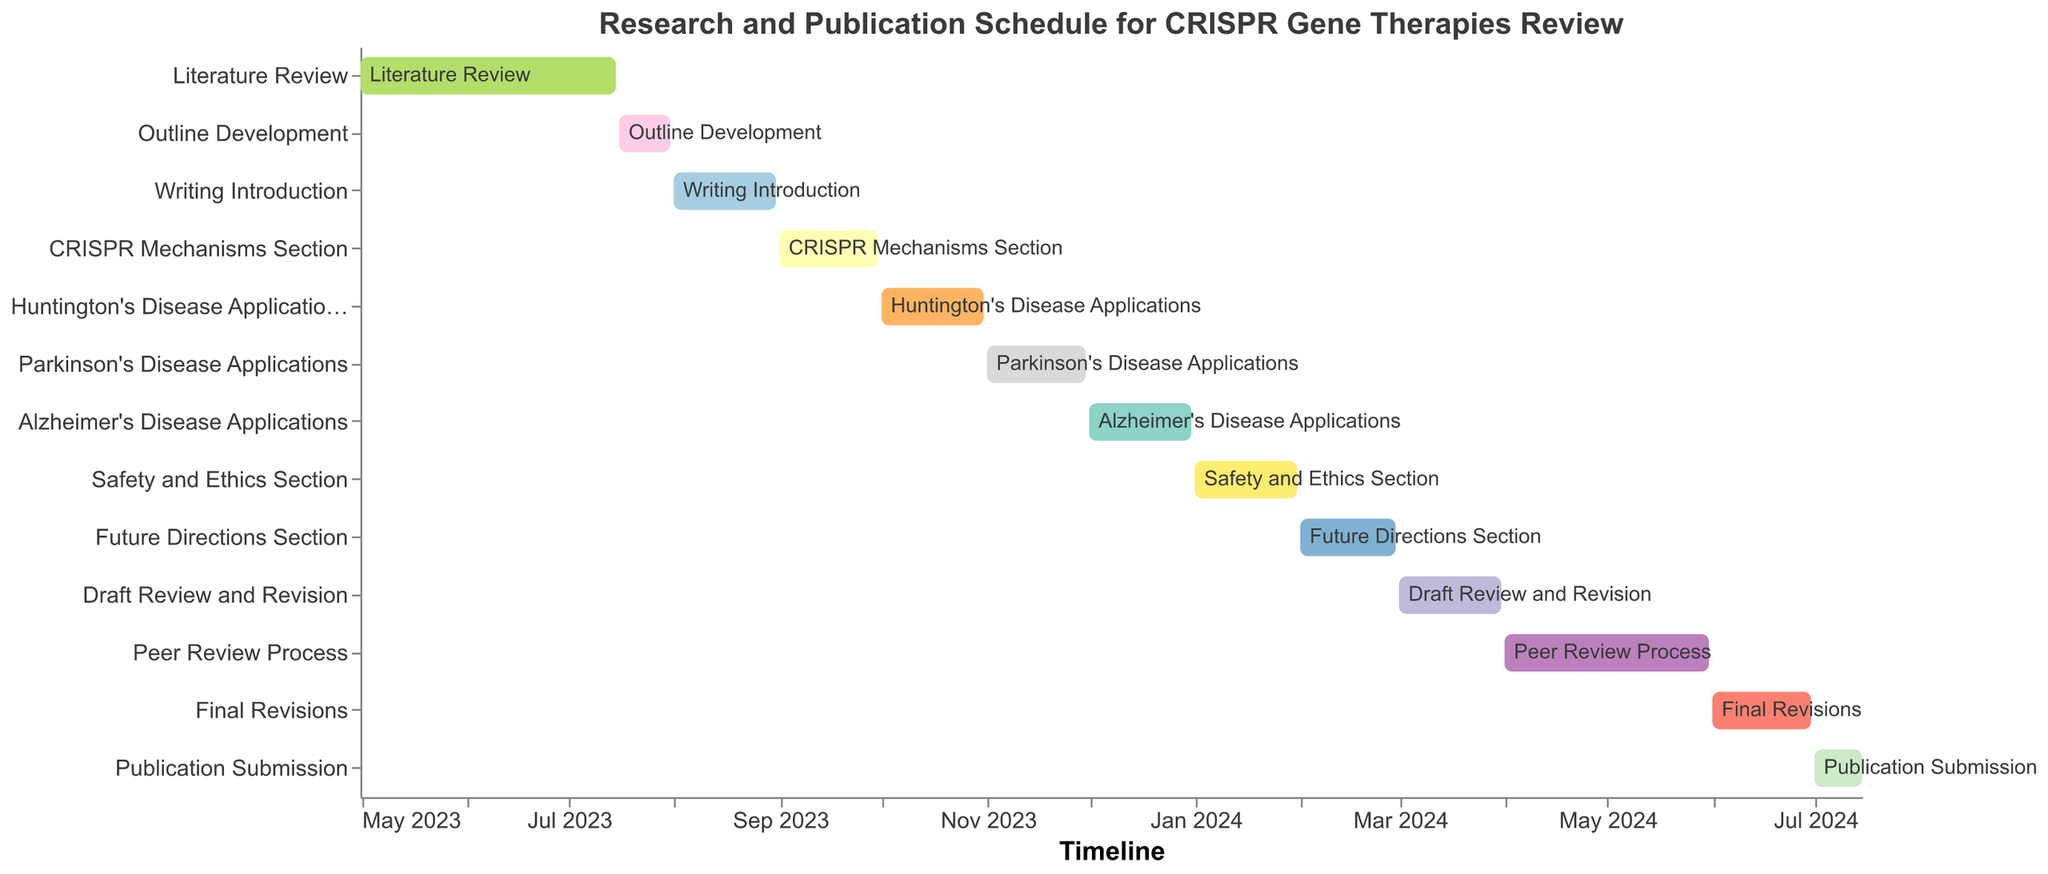What is the first task in the research and publication schedule? The Gantt Chart visually starts with the "Literature Review" task, which is positioned at the top and begins on the earliest date in the timeline, May 1, 2023.
Answer: Literature Review What is the duration of the "Writing Introduction" task? The "Writing Introduction" task starts on August 1, 2023, and ends on August 31, 2023. The duration is the difference between these dates.
Answer: 31 days Which task has the shortest duration? By examining the start and end dates of all tasks, we see the "Outline Development" task from July 16, 2023, to July 31, 2023, has the shortest duration.
Answer: Outline Development How many tasks are scheduled to be completed in the year 2023? There are seven tasks scheduled to finish in 2023: Literature Review, Outline Development, Writing Introduction, CRISPR Mechanisms Section, Huntington's Disease Applications, Parkinson's Disease Applications, and Alzheimer's Disease Applications.
Answer: 7 Which task overlaps with the "Peer Review Process" and by how many days? The "Peer Review Process" overlaps with "Draft Review and Revision" and "Final Revisions". "Peer Review Process" begins on April 1, 2024, and "Draft Review and Revision" ends on March 31, 2024, so there is no overlap. "Final Revisions" overlap by exactly 30 days: April 1, 2024, to April 30, 2024.
Answer: Final Revisions; 30 days Which task takes place in February 2024, and what is its duration? The "Future Directions Section" task starts on February 1, 2024, and ends on February 29, 2024, covering the whole month. The duration is 29 days.
Answer: Future Directions Section; 29 days When does the "Safety and Ethics Section" task start and end? The "Safety and Ethics Section" task starts on January 1, 2024, and ends on January 31, 2024.
Answer: January 1, 2024; January 31, 2024 Between which two tasks does the "CRISPR Mechanisms Section" task fall? The "CRISPR Mechanisms Section" task falls between the "Writing Introduction," which ends on August 31, 2023, and "Huntington's Disease Applications," which starts on October 1, 2023.
Answer: Writing Introduction; Huntington's Disease Applications Which tasks are scheduled to occur after the "Final Revisions" task? The "Final Revisions" task ends on June 30, 2024. The subsequent task is "Publication Submission," starting on July 1, 2024.
Answer: Publication Submission How long does the entire research and publication schedule span, from the start of the first task to the end of the last? The entire schedule starts with the "Literature Review" on May 1, 2023, and ends with "Publication Submission" on July 15, 2024. The span is 14.5 months, calculated by counting the complete months from May 2023 to June 2024 plus half of July 2024.
Answer: 14.5 months 